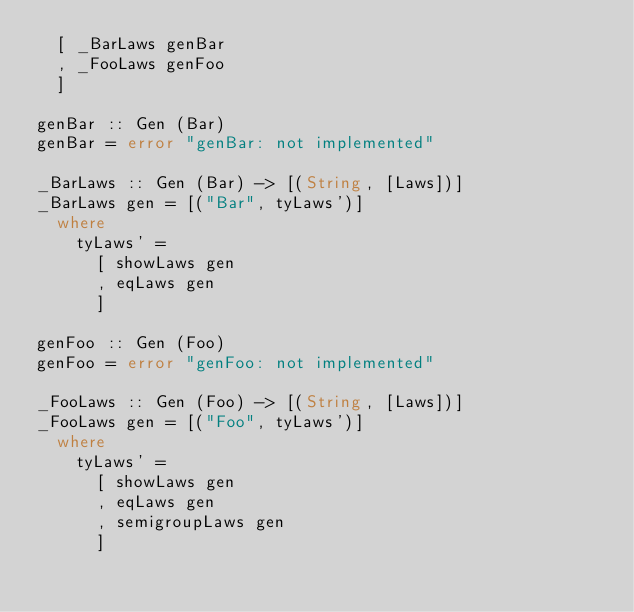<code> <loc_0><loc_0><loc_500><loc_500><_Haskell_>  [ _BarLaws genBar
  , _FooLaws genFoo
  ]

genBar :: Gen (Bar)
genBar = error "genBar: not implemented"

_BarLaws :: Gen (Bar) -> [(String, [Laws])]
_BarLaws gen = [("Bar", tyLaws')]
  where
    tyLaws' =
      [ showLaws gen
      , eqLaws gen
      ]

genFoo :: Gen (Foo)
genFoo = error "genFoo: not implemented"

_FooLaws :: Gen (Foo) -> [(String, [Laws])]
_FooLaws gen = [("Foo", tyLaws')]
  where
    tyLaws' =
      [ showLaws gen
      , eqLaws gen
      , semigroupLaws gen
      ]


</code> 